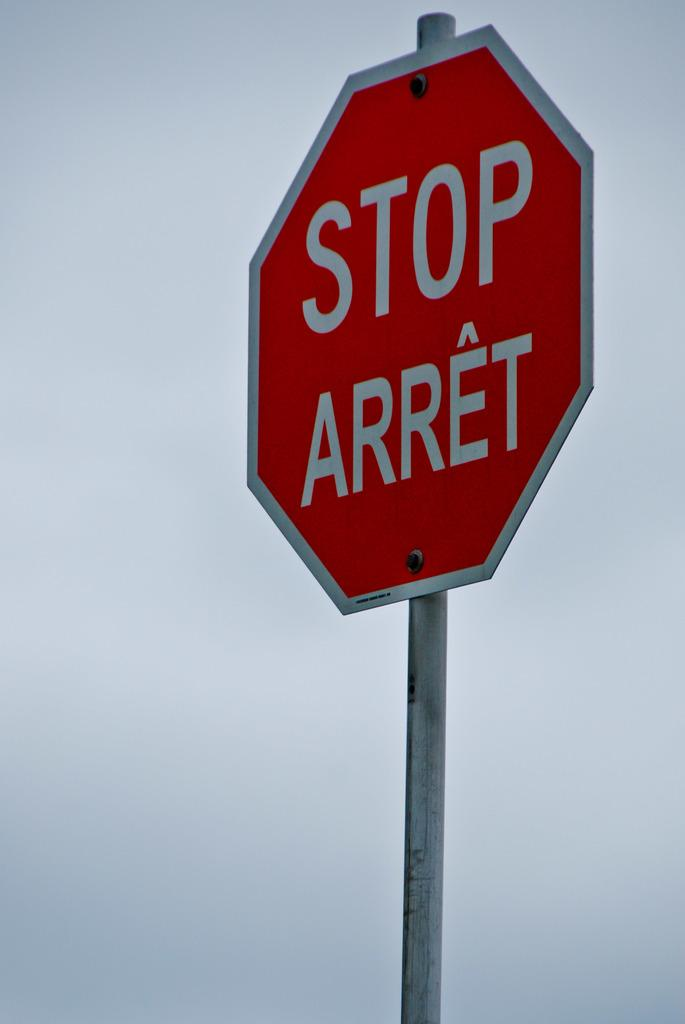<image>
Give a short and clear explanation of the subsequent image. A sign that says STOP ARRET on it. 